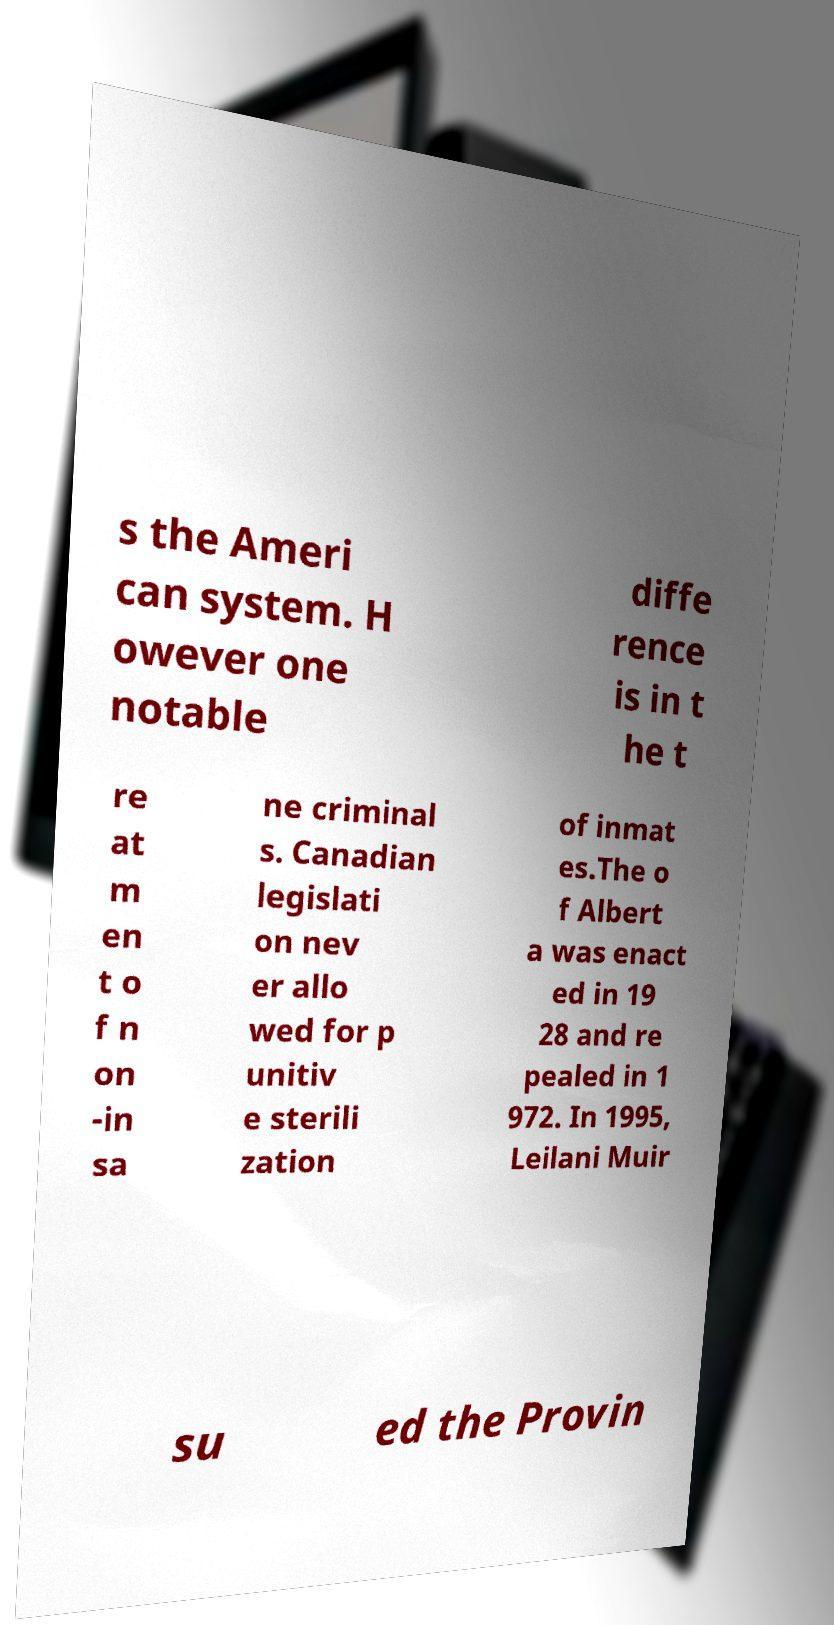Can you accurately transcribe the text from the provided image for me? s the Ameri can system. H owever one notable diffe rence is in t he t re at m en t o f n on -in sa ne criminal s. Canadian legislati on nev er allo wed for p unitiv e sterili zation of inmat es.The o f Albert a was enact ed in 19 28 and re pealed in 1 972. In 1995, Leilani Muir su ed the Provin 